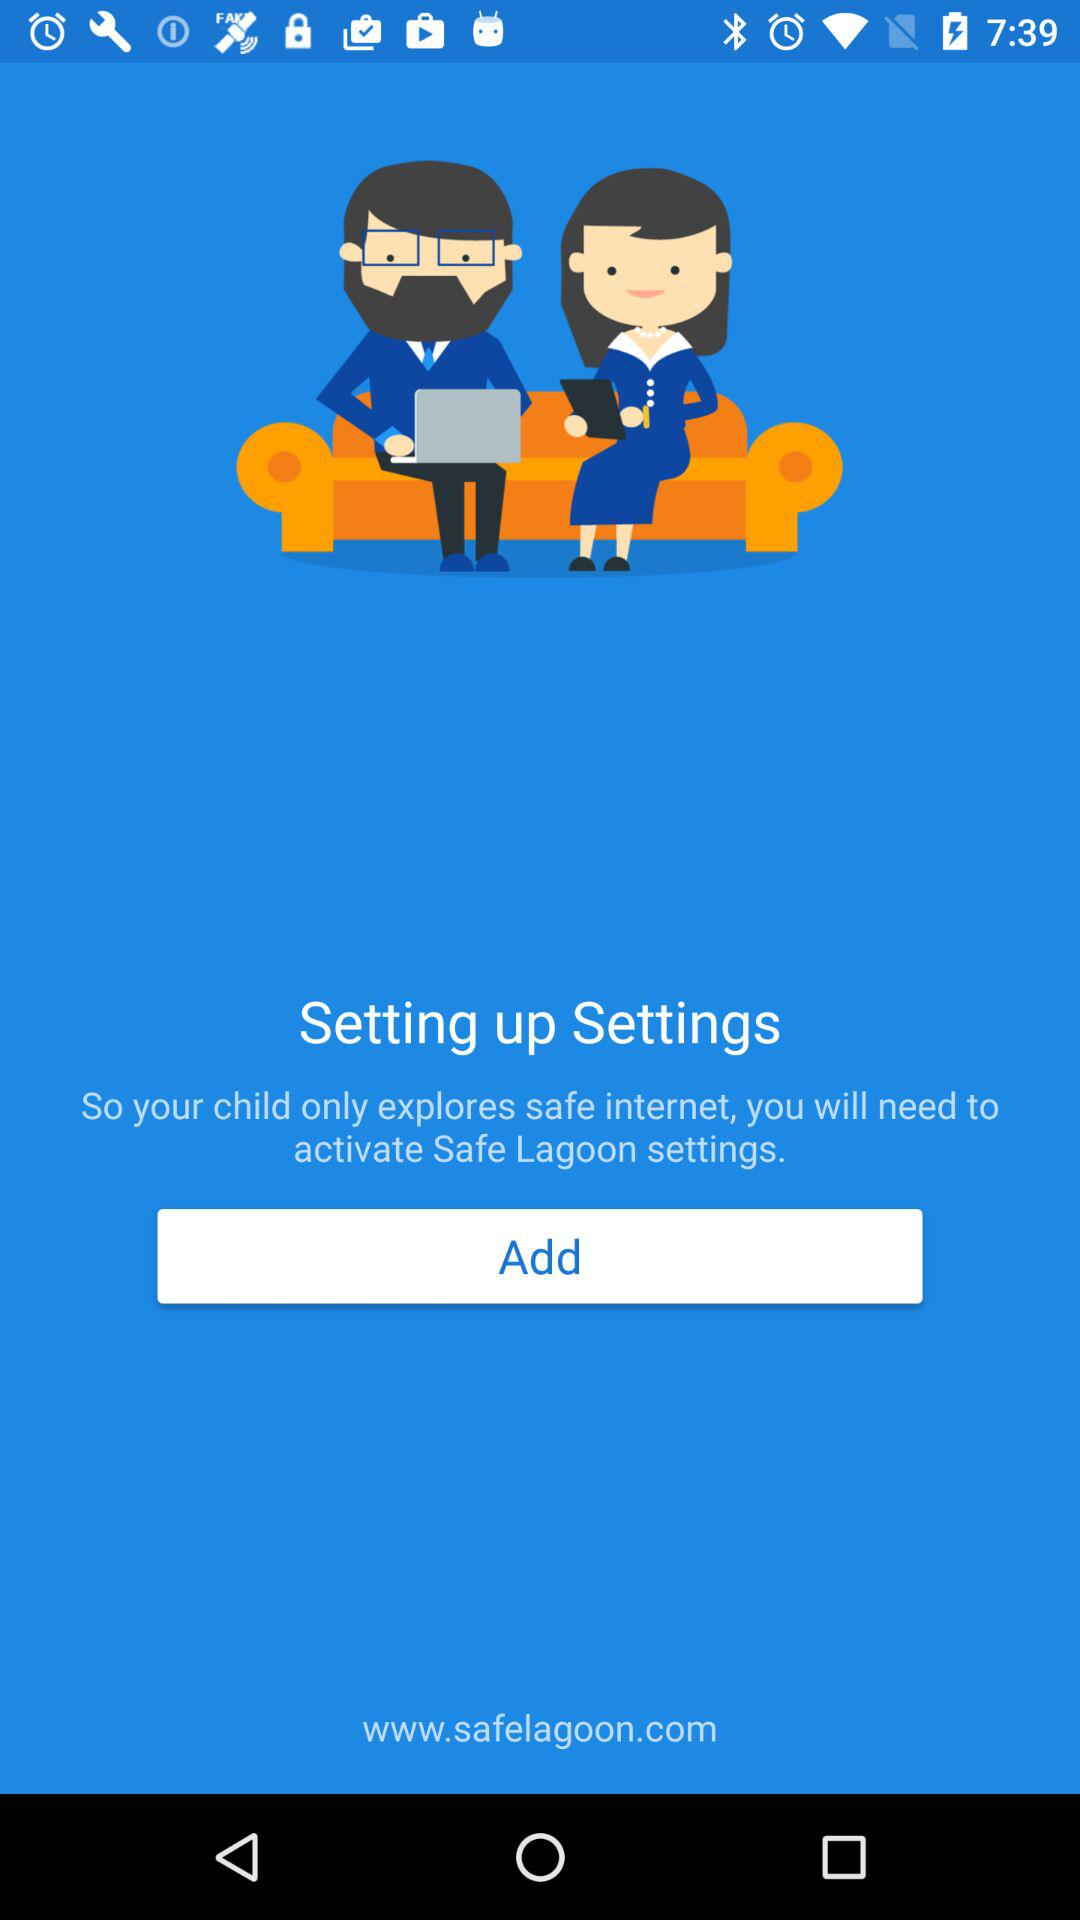What is the application name? The application name is "Safe Lagoon". 